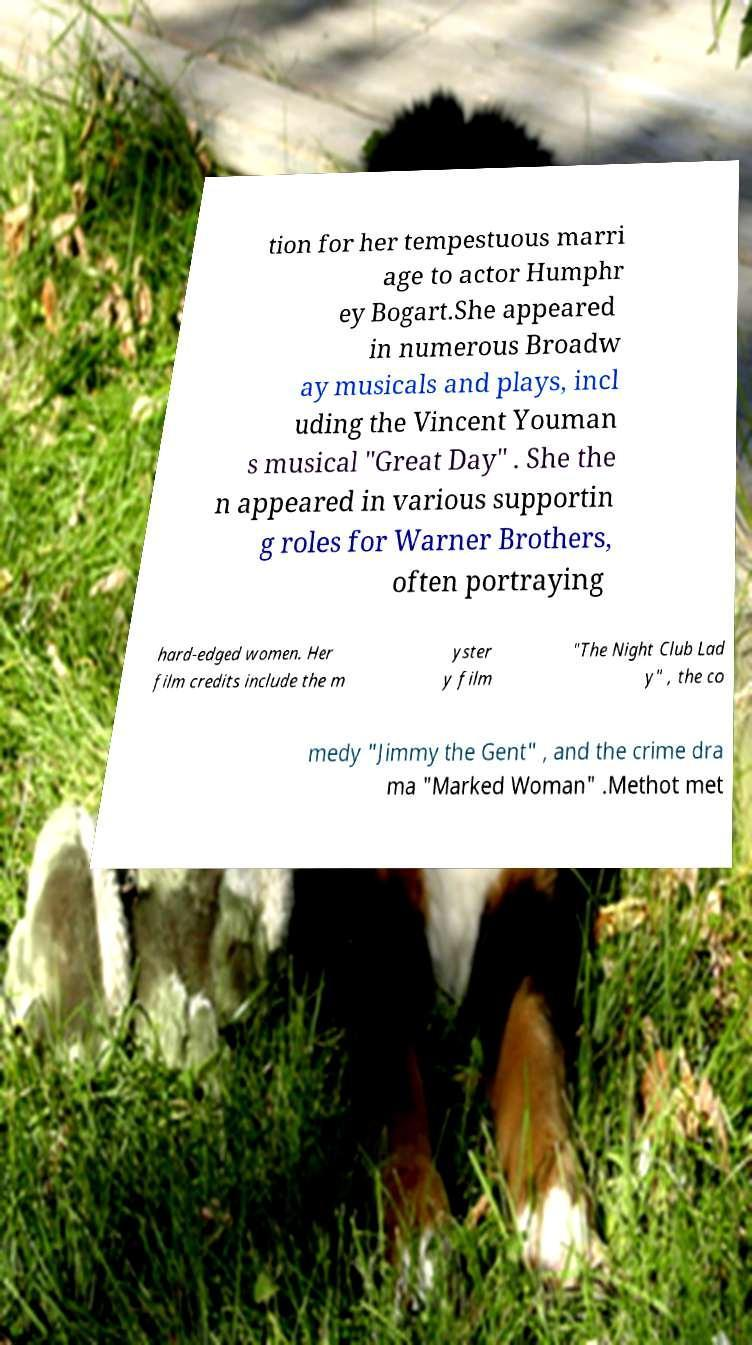For documentation purposes, I need the text within this image transcribed. Could you provide that? tion for her tempestuous marri age to actor Humphr ey Bogart.She appeared in numerous Broadw ay musicals and plays, incl uding the Vincent Youman s musical "Great Day" . She the n appeared in various supportin g roles for Warner Brothers, often portraying hard-edged women. Her film credits include the m yster y film "The Night Club Lad y" , the co medy "Jimmy the Gent" , and the crime dra ma "Marked Woman" .Methot met 